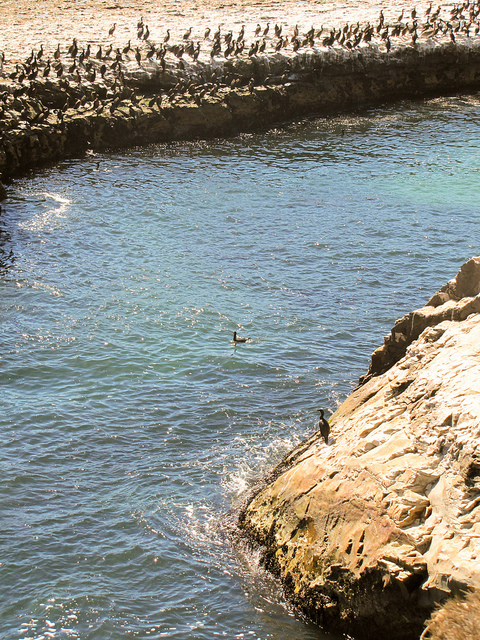How many species of birds can typically be seen in this kind of marine environment? In a marine environment such as this, it's common to observe several species, including seabirds like gulls, cormorants, and pelicans. Each species has unique adaptations, such as webbed feet or specialized bills, which allow them to thrive along coastlines or open water. Do these birds play a role in the ecosystem here? Absolutely, they play a crucial role in the ecosystem. These birds are often indicators of marine health as they feed on fish and other marine life. Their presence and population can reflect the availability of food resources and the overall condition of the marine habitat. 